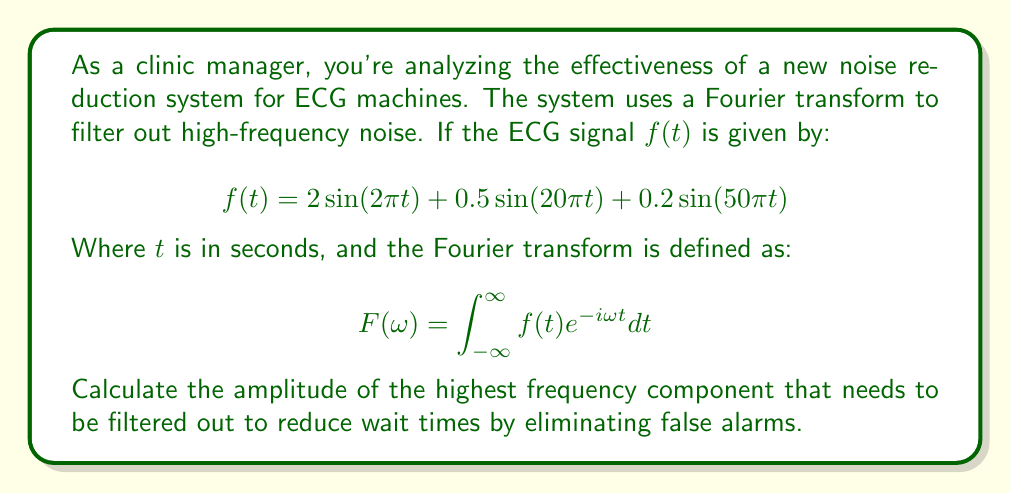Give your solution to this math problem. To solve this problem, we'll follow these steps:

1) First, we need to identify the frequency components in the given signal $f(t)$:
   
   $$f(t) = 2\sin(2\pi t) + 0.5\sin(20\pi t) + 0.2\sin(50\pi t)$$

2) The general form of a sine wave is $A\sin(2\pi ft)$, where $A$ is the amplitude and $f$ is the frequency.

3) For the first term: $2\sin(2\pi t)$
   Frequency $f_1 = 1$ Hz, Amplitude $A_1 = 2$

4) For the second term: $0.5\sin(20\pi t)$
   Frequency $f_2 = 10$ Hz, Amplitude $A_2 = 0.5$

5) For the third term: $0.2\sin(50\pi t)$
   Frequency $f_3 = 25$ Hz, Amplitude $A_3 = 0.2$

6) The highest frequency component is the one with the highest frequency, which is the third term with $f_3 = 25$ Hz.

7) The amplitude of this highest frequency component is $A_3 = 0.2$.

Therefore, to filter out the highest frequency noise and potentially reduce false alarms and wait times, we need to remove the component with an amplitude of 0.2.
Answer: 0.2 